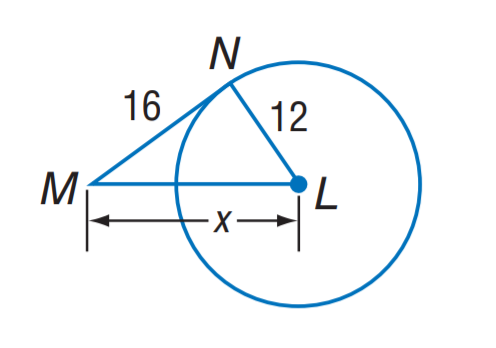Answer the mathemtical geometry problem and directly provide the correct option letter.
Question: The segment is tangent to the circle. Find x.
Choices: A: 12 B: 16 C: 20 D: 22 C 